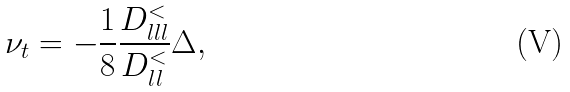Convert formula to latex. <formula><loc_0><loc_0><loc_500><loc_500>\nu _ { t } = - \frac { 1 } { 8 } \frac { D _ { l l l } ^ { < } } { D _ { l l } ^ { < } } \Delta ,</formula> 